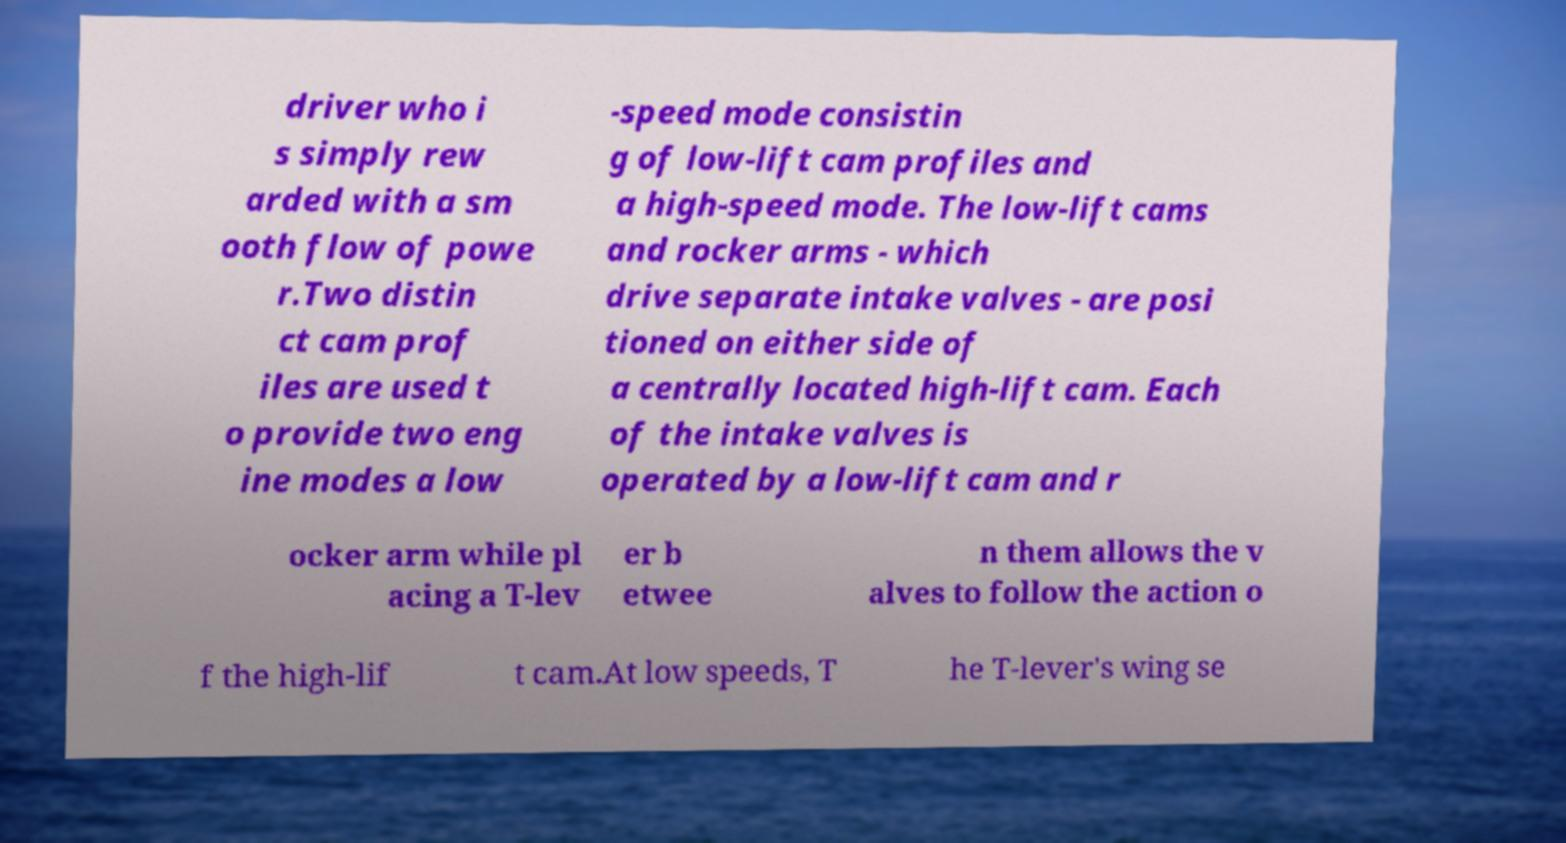I need the written content from this picture converted into text. Can you do that? driver who i s simply rew arded with a sm ooth flow of powe r.Two distin ct cam prof iles are used t o provide two eng ine modes a low -speed mode consistin g of low-lift cam profiles and a high-speed mode. The low-lift cams and rocker arms - which drive separate intake valves - are posi tioned on either side of a centrally located high-lift cam. Each of the intake valves is operated by a low-lift cam and r ocker arm while pl acing a T-lev er b etwee n them allows the v alves to follow the action o f the high-lif t cam.At low speeds, T he T-lever's wing se 